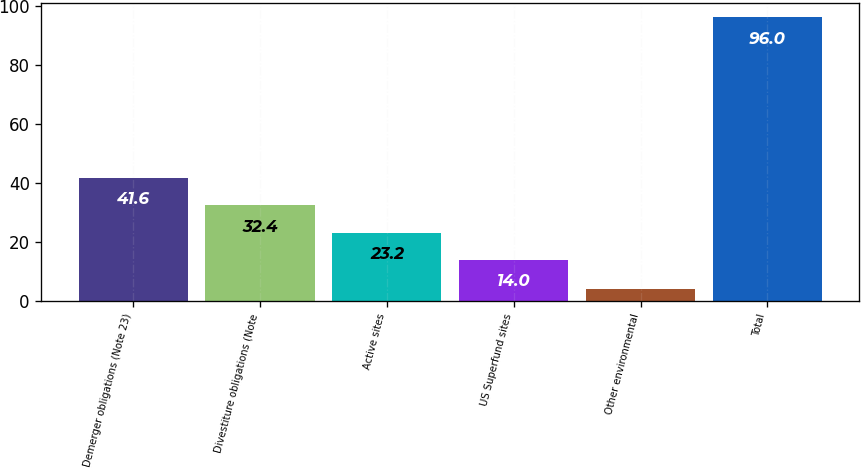<chart> <loc_0><loc_0><loc_500><loc_500><bar_chart><fcel>Demerger obligations (Note 23)<fcel>Divestiture obligations (Note<fcel>Active sites<fcel>US Superfund sites<fcel>Other environmental<fcel>Total<nl><fcel>41.6<fcel>32.4<fcel>23.2<fcel>14<fcel>4<fcel>96<nl></chart> 